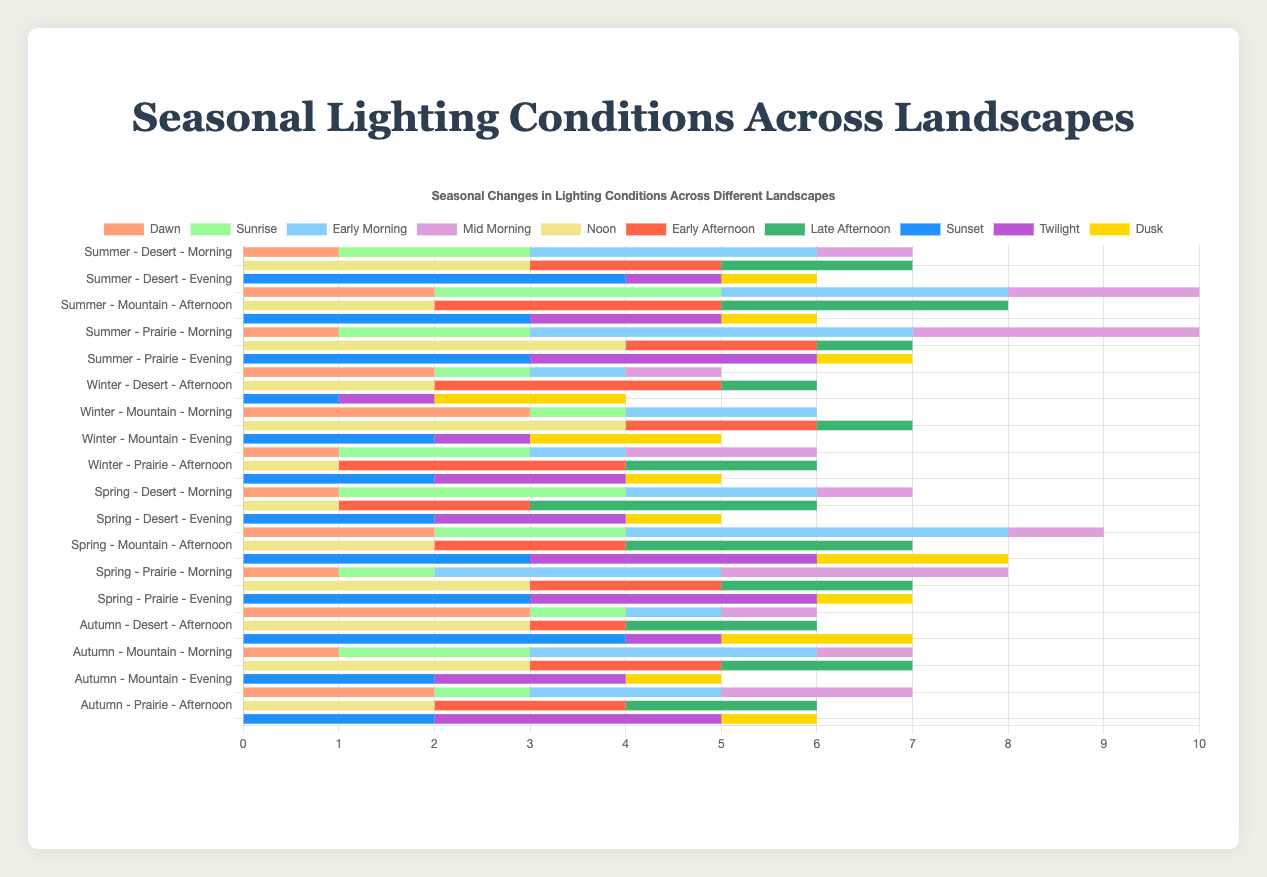Which landscape in Summer has the longest duration of Sunset? In Summer, the Desert landscape has 4 units of Sunset while the Mountain and Prairie have 3 units each. Therefore, Desert has the longest duration of Sunset.
Answer: Desert Which season has the shortest total duration of Dawn in the Desert? Dawn durations in Desert are: Summer (1), Winter (2), Spring (1), Autumn (3). The shortest is 1, which occurs in Summer and Spring.
Answer: Summer and Spring What is the total duration of light conditions in the Morning across all landscapes during Winter? For Winter Morning: Desert (5), Mountain (6), Prairie (6), sum up to 5 + 6 + 6 = 17 units.
Answer: 17 Compare the total duration of lighting conditions in Evening for Prairies during Spring and Autumn. Which season has longer duration and by how much? Prairie in Spring Evening (Sunset 3 + Twilight 3 + Dusk 1 = 7), Autumn Evening (Sunset 2 + Twilight 3 + Dusk 1 = 6). Spring has 1 unit longer duration than Autumn.
Answer: Spring by 1 unit In which season does the Mountain landscape experience the highest duration of Early Morning? The Mountain landscape has Early Morning durations: Summer (3), Winter (2), Spring (4), Autumn (3). The highest is in Spring with 4 units.
Answer: Spring What are the lighting conditions with the same total duration in the Prairie during Winter Afternoon? In Winter Afternoon, Prairie has Noon (1), Early Afternoon (3), Late Afternoon (2). Both Noon and Late Afternoon have 2 units.
Answer: Noon and Late Afternoon Calculate the combined duration of Noon and Sunset in the Mountain across all seasons. Noon durations: Summer (2), Winter (4), Spring (2), Autumn (3) = 2+4+2+3=11. Sunset durations: Summer (3), Winter (2), Spring (3), Autumn (2) = 3+2+3+2=10. Combined: 11 + 10 = 21 units.
Answer: 21 Which landscape and time of day combination in any season has the longest total duration of Twilight? Twilight durations: Desert-Summer (1), Mountain-Summer (2), Prairie-Summer (3), Desert-Winter (1), Mountain-Winter (1), Prairie-Winter (2), Desert-Spring (2), Mountain-Spring (3), Prairie-Spring (3), Desert-Autumn (1), Mountain-Autumn (2), Prairie-Autumn (3). The longest duration is 3 units found in Prairie-Summer, Mountain-Spring, Prairie-Spring, and Prairie-Autumn.
Answer: Prairie-Summer, Mountain-Spring, Prairie-Spring, Prairie-Autumn 